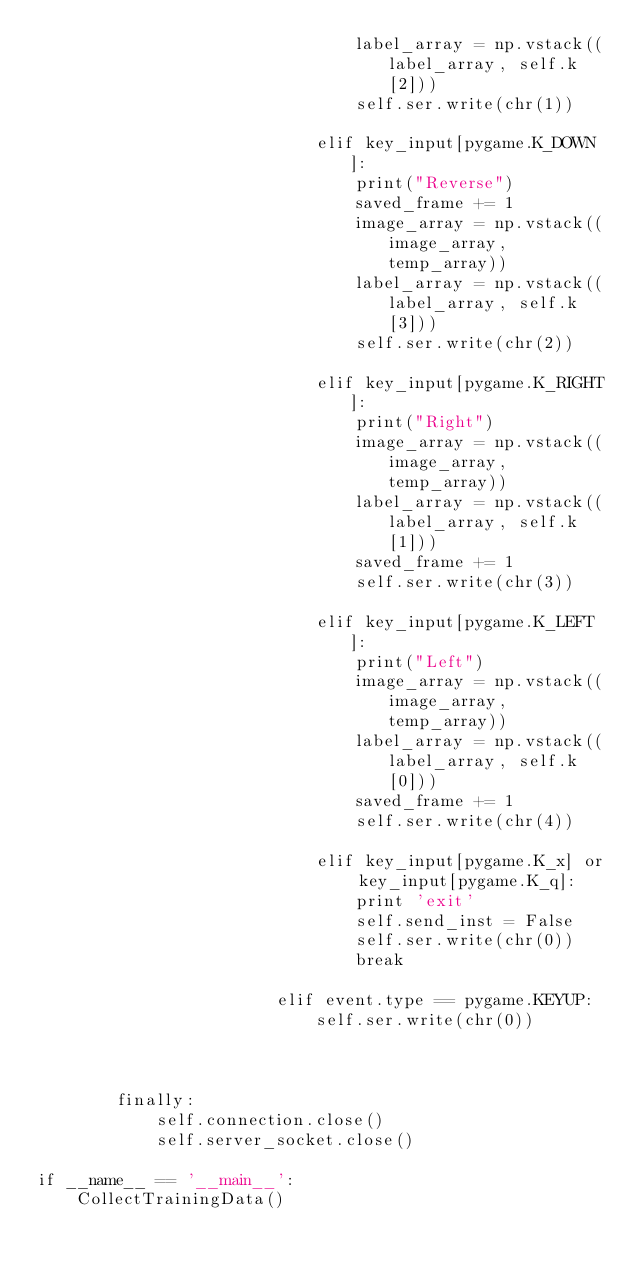<code> <loc_0><loc_0><loc_500><loc_500><_Python_>                                label_array = np.vstack((label_array, self.k[2]))
                                self.ser.write(chr(1))

                            elif key_input[pygame.K_DOWN]:
                                print("Reverse")
                                saved_frame += 1
                                image_array = np.vstack((image_array, temp_array))
                                label_array = np.vstack((label_array, self.k[3]))
                                self.ser.write(chr(2))
                            
                            elif key_input[pygame.K_RIGHT]:
                                print("Right")
                                image_array = np.vstack((image_array, temp_array))
                                label_array = np.vstack((label_array, self.k[1]))
                                saved_frame += 1
                                self.ser.write(chr(3))

                            elif key_input[pygame.K_LEFT]:
                                print("Left")
                                image_array = np.vstack((image_array, temp_array))
                                label_array = np.vstack((label_array, self.k[0]))
                                saved_frame += 1
                                self.ser.write(chr(4))

                            elif key_input[pygame.K_x] or key_input[pygame.K_q]:
                                print 'exit'
                                self.send_inst = False
                                self.ser.write(chr(0))
                                break
                                    
                        elif event.type == pygame.KEYUP:
                            self.ser.write(chr(0))

            

        finally:
            self.connection.close()
            self.server_socket.close()

if __name__ == '__main__':
    CollectTrainingData()</code> 